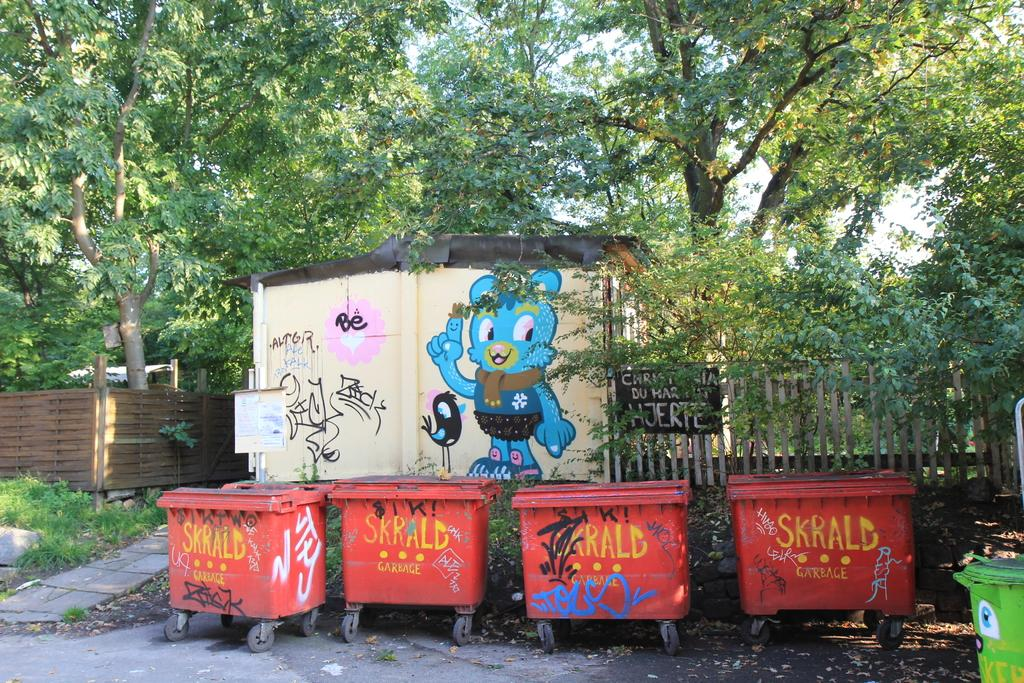Provide a one-sentence caption for the provided image. Four red Skrald Garbage containers sitting in front of a wood fence. 